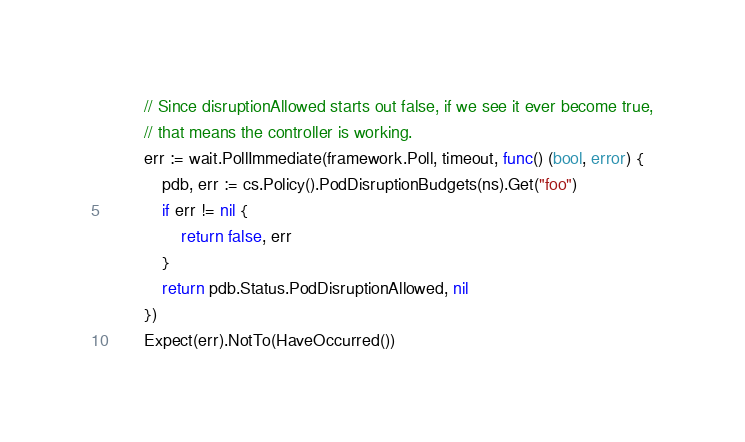<code> <loc_0><loc_0><loc_500><loc_500><_Go_>		// Since disruptionAllowed starts out false, if we see it ever become true,
		// that means the controller is working.
		err := wait.PollImmediate(framework.Poll, timeout, func() (bool, error) {
			pdb, err := cs.Policy().PodDisruptionBudgets(ns).Get("foo")
			if err != nil {
				return false, err
			}
			return pdb.Status.PodDisruptionAllowed, nil
		})
		Expect(err).NotTo(HaveOccurred())
</code> 